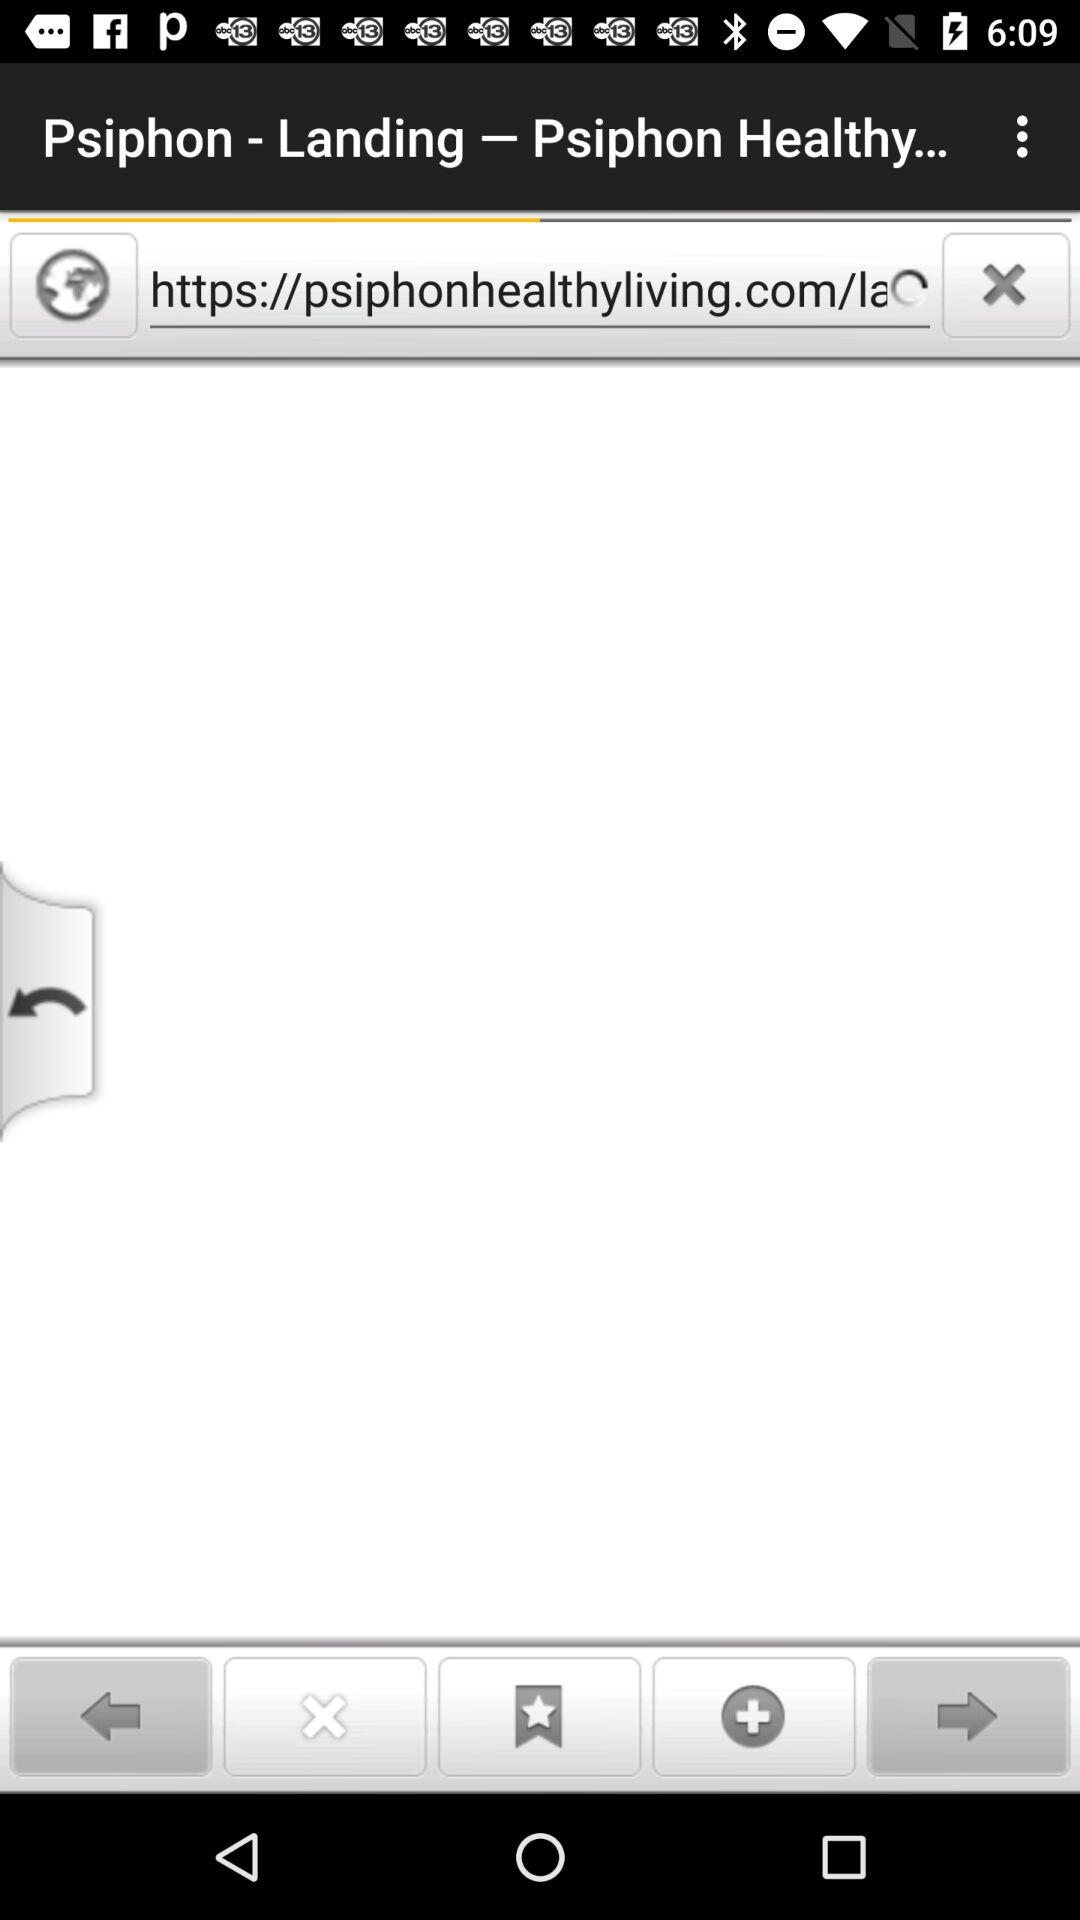What is the app name?
When the provided information is insufficient, respond with <no answer>. <no answer> 